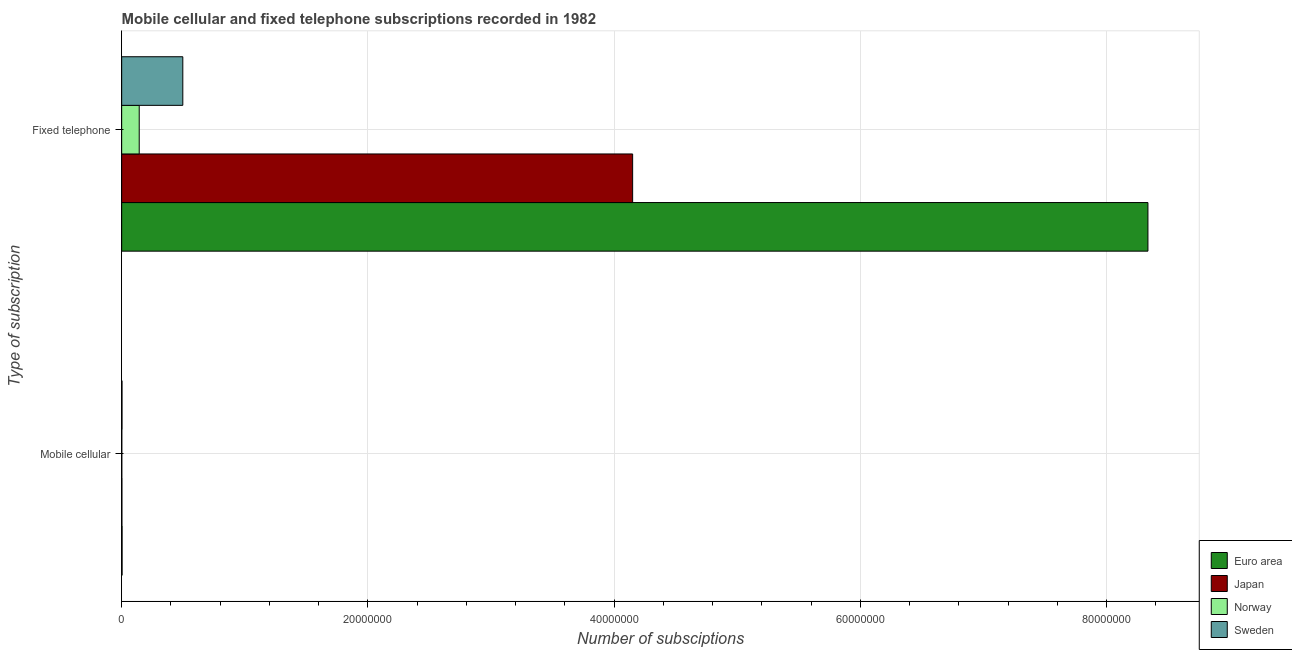Are the number of bars per tick equal to the number of legend labels?
Provide a succinct answer. Yes. How many bars are there on the 2nd tick from the bottom?
Offer a very short reply. 4. What is the label of the 1st group of bars from the top?
Make the answer very short. Fixed telephone. What is the number of mobile cellular subscriptions in Japan?
Ensure brevity in your answer.  1.98e+04. Across all countries, what is the maximum number of fixed telephone subscriptions?
Make the answer very short. 8.34e+07. Across all countries, what is the minimum number of fixed telephone subscriptions?
Give a very brief answer. 1.43e+06. What is the total number of mobile cellular subscriptions in the graph?
Keep it short and to the point. 9.20e+04. What is the difference between the number of mobile cellular subscriptions in Norway and that in Japan?
Keep it short and to the point. -8745. What is the difference between the number of fixed telephone subscriptions in Japan and the number of mobile cellular subscriptions in Sweden?
Make the answer very short. 4.15e+07. What is the average number of mobile cellular subscriptions per country?
Give a very brief answer. 2.30e+04. What is the difference between the number of mobile cellular subscriptions and number of fixed telephone subscriptions in Norway?
Give a very brief answer. -1.41e+06. What is the ratio of the number of fixed telephone subscriptions in Norway to that in Japan?
Your response must be concise. 0.03. Is the number of fixed telephone subscriptions in Japan less than that in Norway?
Make the answer very short. No. What does the 4th bar from the top in Fixed telephone represents?
Keep it short and to the point. Euro area. How many countries are there in the graph?
Ensure brevity in your answer.  4. What is the difference between two consecutive major ticks on the X-axis?
Your answer should be compact. 2.00e+07. Where does the legend appear in the graph?
Ensure brevity in your answer.  Bottom right. How many legend labels are there?
Ensure brevity in your answer.  4. How are the legend labels stacked?
Give a very brief answer. Vertical. What is the title of the graph?
Ensure brevity in your answer.  Mobile cellular and fixed telephone subscriptions recorded in 1982. Does "Burkina Faso" appear as one of the legend labels in the graph?
Your response must be concise. No. What is the label or title of the X-axis?
Your answer should be very brief. Number of subsciptions. What is the label or title of the Y-axis?
Ensure brevity in your answer.  Type of subscription. What is the Number of subsciptions in Euro area in Mobile cellular?
Offer a terse response. 3.39e+04. What is the Number of subsciptions in Japan in Mobile cellular?
Make the answer very short. 1.98e+04. What is the Number of subsciptions of Norway in Mobile cellular?
Your answer should be very brief. 1.11e+04. What is the Number of subsciptions of Sweden in Mobile cellular?
Your answer should be compact. 2.72e+04. What is the Number of subsciptions of Euro area in Fixed telephone?
Offer a terse response. 8.34e+07. What is the Number of subsciptions of Japan in Fixed telephone?
Keep it short and to the point. 4.15e+07. What is the Number of subsciptions in Norway in Fixed telephone?
Keep it short and to the point. 1.43e+06. What is the Number of subsciptions of Sweden in Fixed telephone?
Give a very brief answer. 4.97e+06. Across all Type of subscription, what is the maximum Number of subsciptions in Euro area?
Your answer should be compact. 8.34e+07. Across all Type of subscription, what is the maximum Number of subsciptions in Japan?
Your answer should be very brief. 4.15e+07. Across all Type of subscription, what is the maximum Number of subsciptions of Norway?
Offer a very short reply. 1.43e+06. Across all Type of subscription, what is the maximum Number of subsciptions of Sweden?
Provide a short and direct response. 4.97e+06. Across all Type of subscription, what is the minimum Number of subsciptions of Euro area?
Offer a very short reply. 3.39e+04. Across all Type of subscription, what is the minimum Number of subsciptions of Japan?
Offer a terse response. 1.98e+04. Across all Type of subscription, what is the minimum Number of subsciptions in Norway?
Keep it short and to the point. 1.11e+04. Across all Type of subscription, what is the minimum Number of subsciptions of Sweden?
Your response must be concise. 2.72e+04. What is the total Number of subsciptions in Euro area in the graph?
Keep it short and to the point. 8.34e+07. What is the total Number of subsciptions of Japan in the graph?
Give a very brief answer. 4.15e+07. What is the total Number of subsciptions of Norway in the graph?
Offer a very short reply. 1.44e+06. What is the total Number of subsciptions of Sweden in the graph?
Your answer should be very brief. 4.99e+06. What is the difference between the Number of subsciptions in Euro area in Mobile cellular and that in Fixed telephone?
Provide a succinct answer. -8.33e+07. What is the difference between the Number of subsciptions in Japan in Mobile cellular and that in Fixed telephone?
Provide a succinct answer. -4.15e+07. What is the difference between the Number of subsciptions of Norway in Mobile cellular and that in Fixed telephone?
Provide a short and direct response. -1.41e+06. What is the difference between the Number of subsciptions of Sweden in Mobile cellular and that in Fixed telephone?
Ensure brevity in your answer.  -4.94e+06. What is the difference between the Number of subsciptions in Euro area in Mobile cellular and the Number of subsciptions in Japan in Fixed telephone?
Your answer should be compact. -4.15e+07. What is the difference between the Number of subsciptions of Euro area in Mobile cellular and the Number of subsciptions of Norway in Fixed telephone?
Give a very brief answer. -1.39e+06. What is the difference between the Number of subsciptions in Euro area in Mobile cellular and the Number of subsciptions in Sweden in Fixed telephone?
Give a very brief answer. -4.93e+06. What is the difference between the Number of subsciptions of Japan in Mobile cellular and the Number of subsciptions of Norway in Fixed telephone?
Offer a very short reply. -1.41e+06. What is the difference between the Number of subsciptions of Japan in Mobile cellular and the Number of subsciptions of Sweden in Fixed telephone?
Offer a very short reply. -4.95e+06. What is the difference between the Number of subsciptions in Norway in Mobile cellular and the Number of subsciptions in Sweden in Fixed telephone?
Keep it short and to the point. -4.95e+06. What is the average Number of subsciptions in Euro area per Type of subscription?
Keep it short and to the point. 4.17e+07. What is the average Number of subsciptions of Japan per Type of subscription?
Give a very brief answer. 2.08e+07. What is the average Number of subsciptions of Norway per Type of subscription?
Ensure brevity in your answer.  7.18e+05. What is the average Number of subsciptions of Sweden per Type of subscription?
Your response must be concise. 2.50e+06. What is the difference between the Number of subsciptions of Euro area and Number of subsciptions of Japan in Mobile cellular?
Ensure brevity in your answer.  1.41e+04. What is the difference between the Number of subsciptions of Euro area and Number of subsciptions of Norway in Mobile cellular?
Provide a short and direct response. 2.28e+04. What is the difference between the Number of subsciptions in Euro area and Number of subsciptions in Sweden in Mobile cellular?
Make the answer very short. 6644. What is the difference between the Number of subsciptions in Japan and Number of subsciptions in Norway in Mobile cellular?
Provide a short and direct response. 8745. What is the difference between the Number of subsciptions in Japan and Number of subsciptions in Sweden in Mobile cellular?
Keep it short and to the point. -7432. What is the difference between the Number of subsciptions in Norway and Number of subsciptions in Sweden in Mobile cellular?
Offer a very short reply. -1.62e+04. What is the difference between the Number of subsciptions in Euro area and Number of subsciptions in Japan in Fixed telephone?
Make the answer very short. 4.19e+07. What is the difference between the Number of subsciptions of Euro area and Number of subsciptions of Norway in Fixed telephone?
Your response must be concise. 8.19e+07. What is the difference between the Number of subsciptions of Euro area and Number of subsciptions of Sweden in Fixed telephone?
Ensure brevity in your answer.  7.84e+07. What is the difference between the Number of subsciptions of Japan and Number of subsciptions of Norway in Fixed telephone?
Give a very brief answer. 4.01e+07. What is the difference between the Number of subsciptions in Japan and Number of subsciptions in Sweden in Fixed telephone?
Make the answer very short. 3.65e+07. What is the difference between the Number of subsciptions in Norway and Number of subsciptions in Sweden in Fixed telephone?
Provide a succinct answer. -3.54e+06. What is the ratio of the Number of subsciptions of Japan in Mobile cellular to that in Fixed telephone?
Offer a very short reply. 0. What is the ratio of the Number of subsciptions in Norway in Mobile cellular to that in Fixed telephone?
Your response must be concise. 0.01. What is the ratio of the Number of subsciptions of Sweden in Mobile cellular to that in Fixed telephone?
Offer a terse response. 0.01. What is the difference between the highest and the second highest Number of subsciptions of Euro area?
Your answer should be very brief. 8.33e+07. What is the difference between the highest and the second highest Number of subsciptions of Japan?
Make the answer very short. 4.15e+07. What is the difference between the highest and the second highest Number of subsciptions of Norway?
Make the answer very short. 1.41e+06. What is the difference between the highest and the second highest Number of subsciptions of Sweden?
Offer a very short reply. 4.94e+06. What is the difference between the highest and the lowest Number of subsciptions of Euro area?
Offer a very short reply. 8.33e+07. What is the difference between the highest and the lowest Number of subsciptions of Japan?
Provide a succinct answer. 4.15e+07. What is the difference between the highest and the lowest Number of subsciptions of Norway?
Your response must be concise. 1.41e+06. What is the difference between the highest and the lowest Number of subsciptions of Sweden?
Offer a terse response. 4.94e+06. 